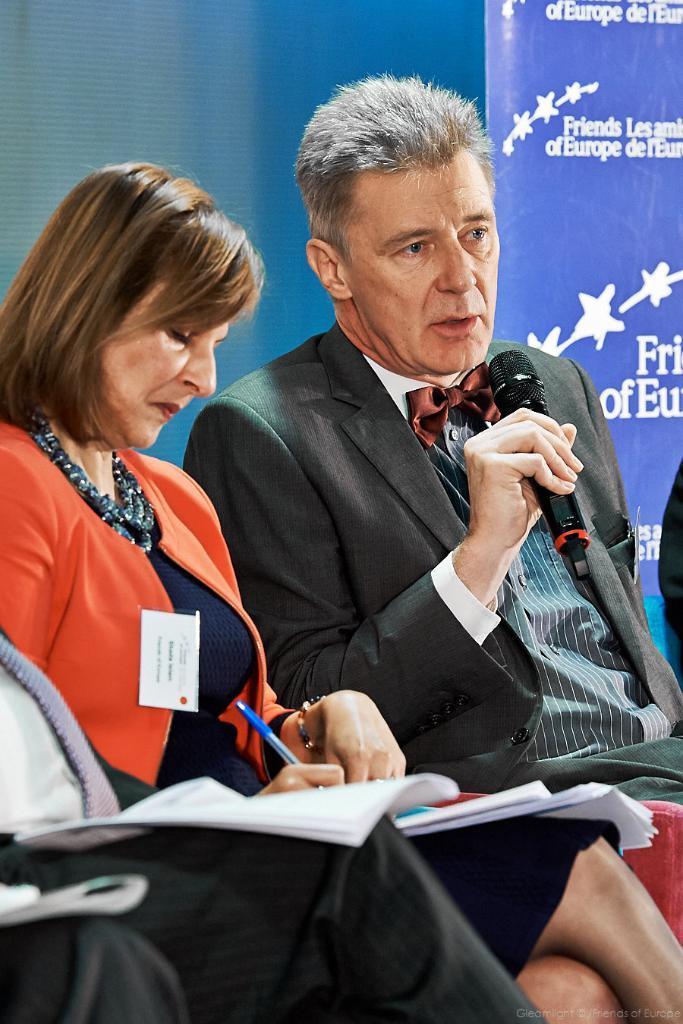Describe this image in one or two sentences. In this image,There are some people sitting and in the left side there is a woman in the orange color coat holding a pen and writing in a book, In the right side there is a man holding a microphone which is in black color, In the background there is a wall of blue color. 